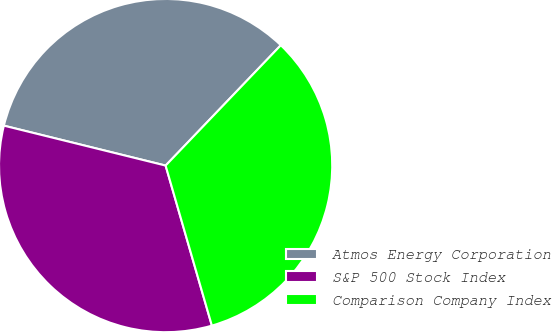Convert chart. <chart><loc_0><loc_0><loc_500><loc_500><pie_chart><fcel>Atmos Energy Corporation<fcel>S&P 500 Stock Index<fcel>Comparison Company Index<nl><fcel>33.3%<fcel>33.33%<fcel>33.37%<nl></chart> 